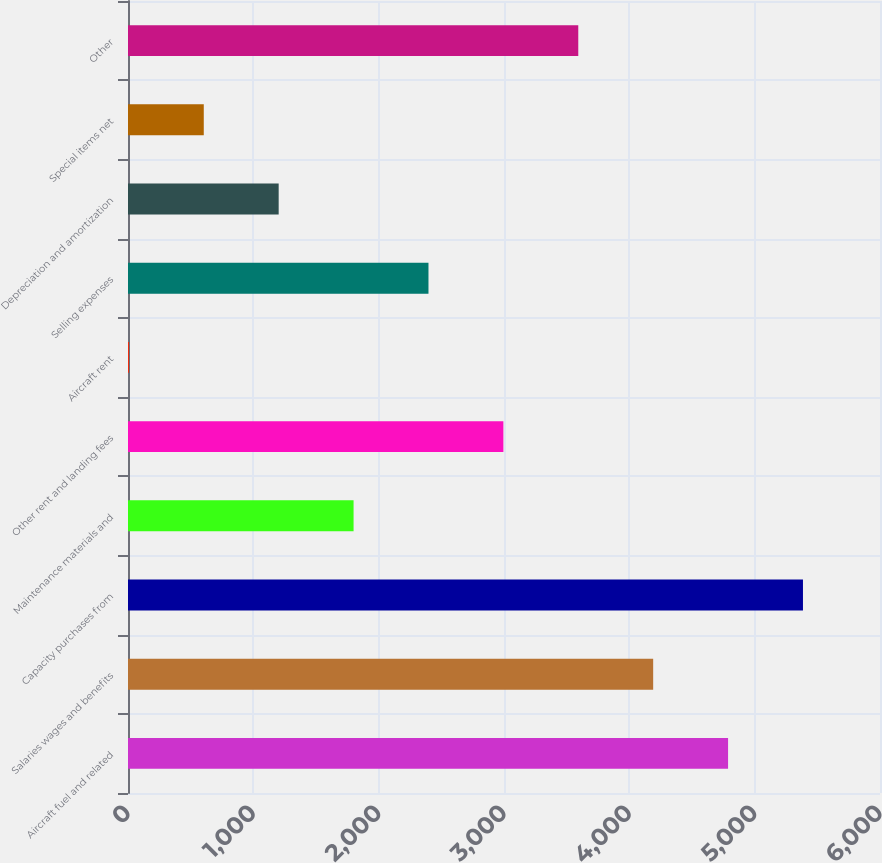Convert chart to OTSL. <chart><loc_0><loc_0><loc_500><loc_500><bar_chart><fcel>Aircraft fuel and related<fcel>Salaries wages and benefits<fcel>Capacity purchases from<fcel>Maintenance materials and<fcel>Other rent and landing fees<fcel>Aircraft rent<fcel>Selling expenses<fcel>Depreciation and amortization<fcel>Special items net<fcel>Other<nl><fcel>4787.8<fcel>4190.2<fcel>5385.4<fcel>1799.8<fcel>2995<fcel>7<fcel>2397.4<fcel>1202.2<fcel>604.6<fcel>3592.6<nl></chart> 